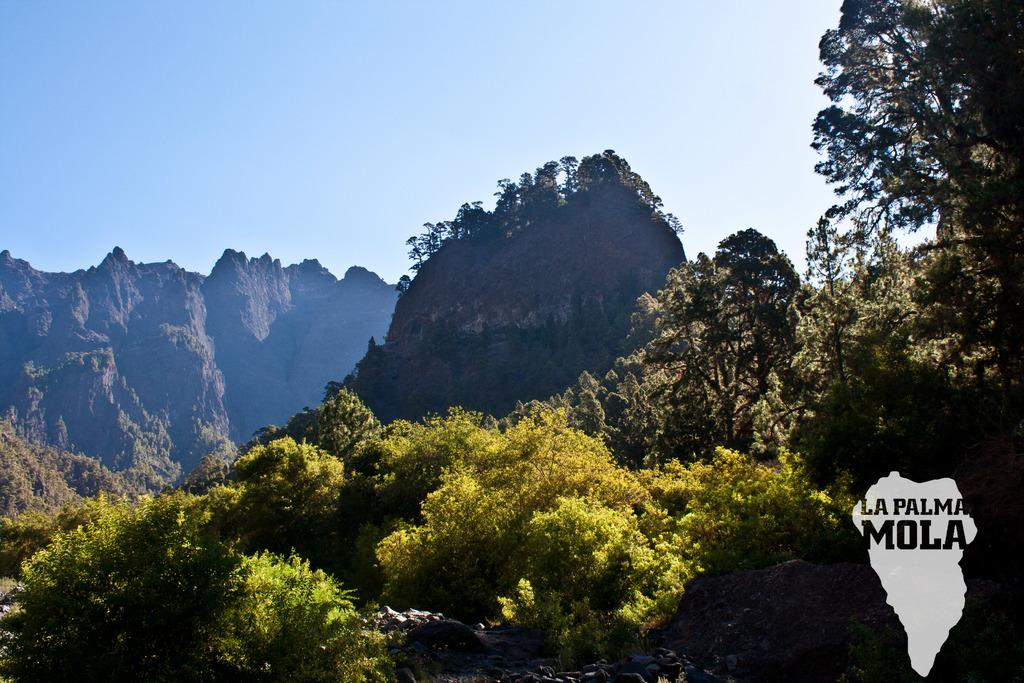What type of natural elements can be seen in the image? There are trees, plants, mountains, and water visible in the image. What man-made elements can be seen in the image? There is text, a map, and stones visible in the image. What part of the natural environment is visible in the image? The sky is visible in the image. Can you determine the time of day the image was taken? The image was likely taken during the day, as the sky is visible and there is no indication of darkness. What is the annual income of the person who took the picture? There is no information about the person who took the picture, nor their income, so it cannot be determined. What type of underwear is visible in the image? There is no underwear present in the image. 